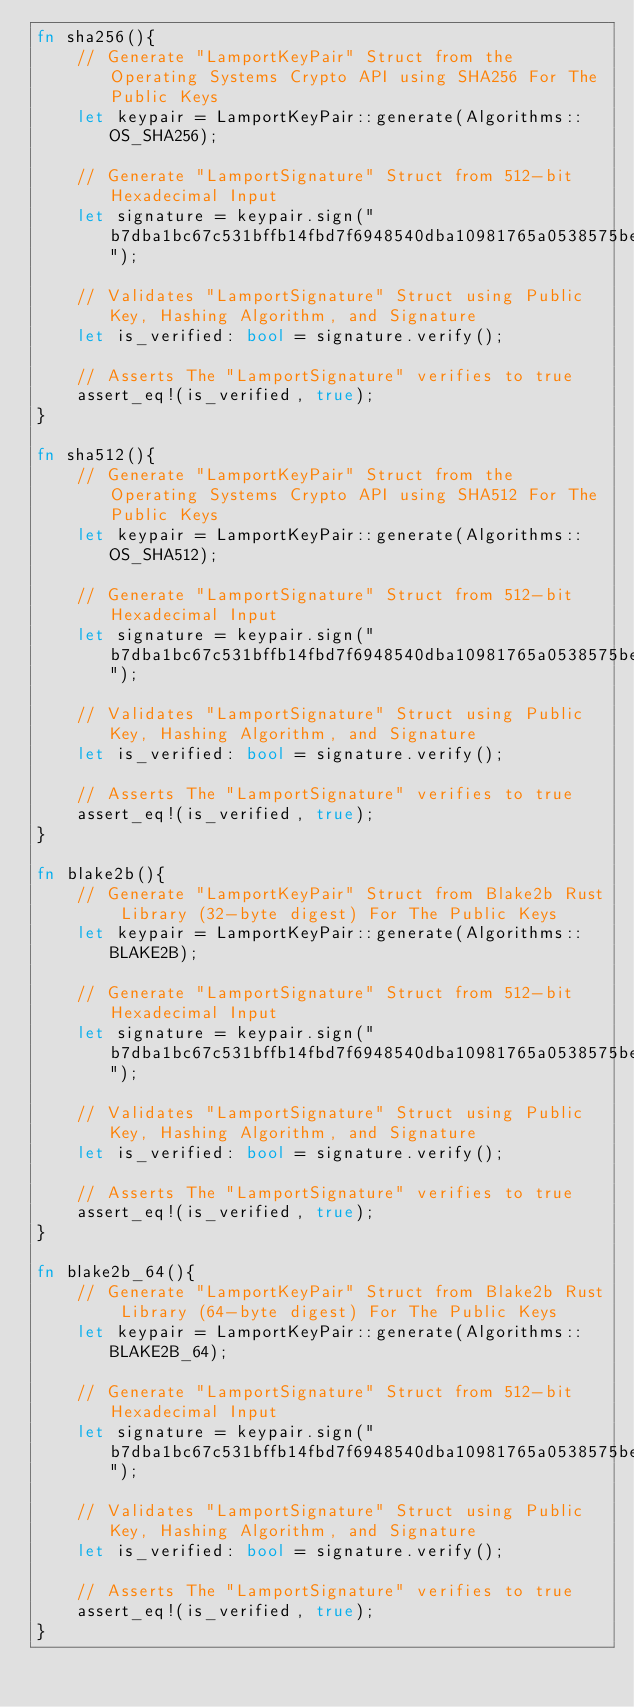Convert code to text. <code><loc_0><loc_0><loc_500><loc_500><_Rust_>fn sha256(){
    // Generate "LamportKeyPair" Struct from the Operating Systems Crypto API using SHA256 For The Public Keys
    let keypair = LamportKeyPair::generate(Algorithms::OS_SHA256);
    
    // Generate "LamportSignature" Struct from 512-bit Hexadecimal Input
    let signature = keypair.sign("b7dba1bc67c531bffb14fbd7f6948540dba10981765a0538575bed2b6bf553d43f35c287635ef7c4cb2c379f71218edaf70d5d73844910684103b99916e428c2");

    // Validates "LamportSignature" Struct using Public Key, Hashing Algorithm, and Signature
    let is_verified: bool = signature.verify();

    // Asserts The "LamportSignature" verifies to true
    assert_eq!(is_verified, true);
}

fn sha512(){
    // Generate "LamportKeyPair" Struct from the Operating Systems Crypto API using SHA512 For The Public Keys
    let keypair = LamportKeyPair::generate(Algorithms::OS_SHA512);
    
    // Generate "LamportSignature" Struct from 512-bit Hexadecimal Input
    let signature = keypair.sign("b7dba1bc67c531bffb14fbd7f6948540dba10981765a0538575bed2b6bf553d43f35c287635ef7c4cb2c379f71218edaf70d5d73844910684103b99916e428c2");

    // Validates "LamportSignature" Struct using Public Key, Hashing Algorithm, and Signature
    let is_verified: bool = signature.verify();

    // Asserts The "LamportSignature" verifies to true
    assert_eq!(is_verified, true);
}

fn blake2b(){
    // Generate "LamportKeyPair" Struct from Blake2b Rust Library (32-byte digest) For The Public Keys
    let keypair = LamportKeyPair::generate(Algorithms::BLAKE2B);

    // Generate "LamportSignature" Struct from 512-bit Hexadecimal Input
    let signature = keypair.sign("b7dba1bc67c531bffb14fbd7f6948540dba10981765a0538575bed2b6bf553d43f35c287635ef7c4cb2c379f71218edaf70d5d73844910684103b99916e428c2");

    // Validates "LamportSignature" Struct using Public Key, Hashing Algorithm, and Signature
    let is_verified: bool = signature.verify();

    // Asserts The "LamportSignature" verifies to true
    assert_eq!(is_verified, true);
}

fn blake2b_64(){
    // Generate "LamportKeyPair" Struct from Blake2b Rust Library (64-byte digest) For The Public Keys
    let keypair = LamportKeyPair::generate(Algorithms::BLAKE2B_64);

    // Generate "LamportSignature" Struct from 512-bit Hexadecimal Input
    let signature = keypair.sign("b7dba1bc67c531bffb14fbd7f6948540dba10981765a0538575bed2b6bf553d43f35c287635ef7c4cb2c379f71218edaf70d5d73844910684103b99916e428c2");

    // Validates "LamportSignature" Struct using Public Key, Hashing Algorithm, and Signature
    let is_verified: bool = signature.verify();

    // Asserts The "LamportSignature" verifies to true
    assert_eq!(is_verified, true);
}</code> 